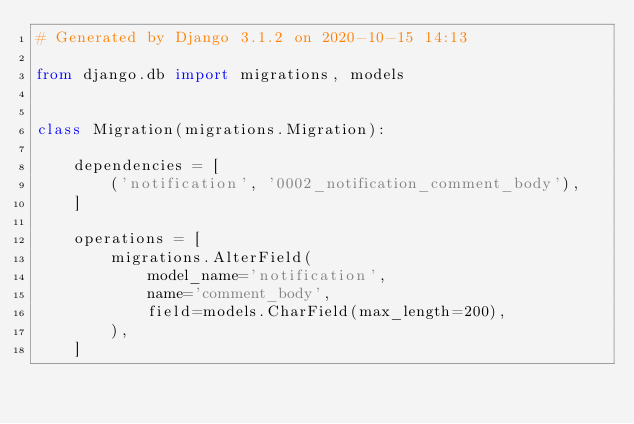Convert code to text. <code><loc_0><loc_0><loc_500><loc_500><_Python_># Generated by Django 3.1.2 on 2020-10-15 14:13

from django.db import migrations, models


class Migration(migrations.Migration):

    dependencies = [
        ('notification', '0002_notification_comment_body'),
    ]

    operations = [
        migrations.AlterField(
            model_name='notification',
            name='comment_body',
            field=models.CharField(max_length=200),
        ),
    ]
</code> 